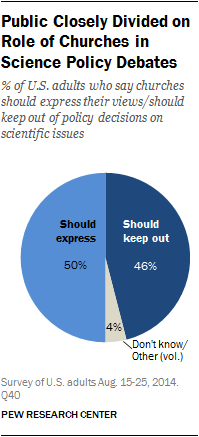List a handful of essential elements in this visual. The result of taking the average of the two largest segments, dividing it by the smallest segment, is 12. The percentage value of the "Should Express Segment" is 50%. 